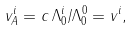Convert formula to latex. <formula><loc_0><loc_0><loc_500><loc_500>v _ { A } ^ { i } = c \, \Lambda ^ { i } _ { 0 } / \Lambda ^ { 0 } _ { 0 } = v ^ { i } ,</formula> 